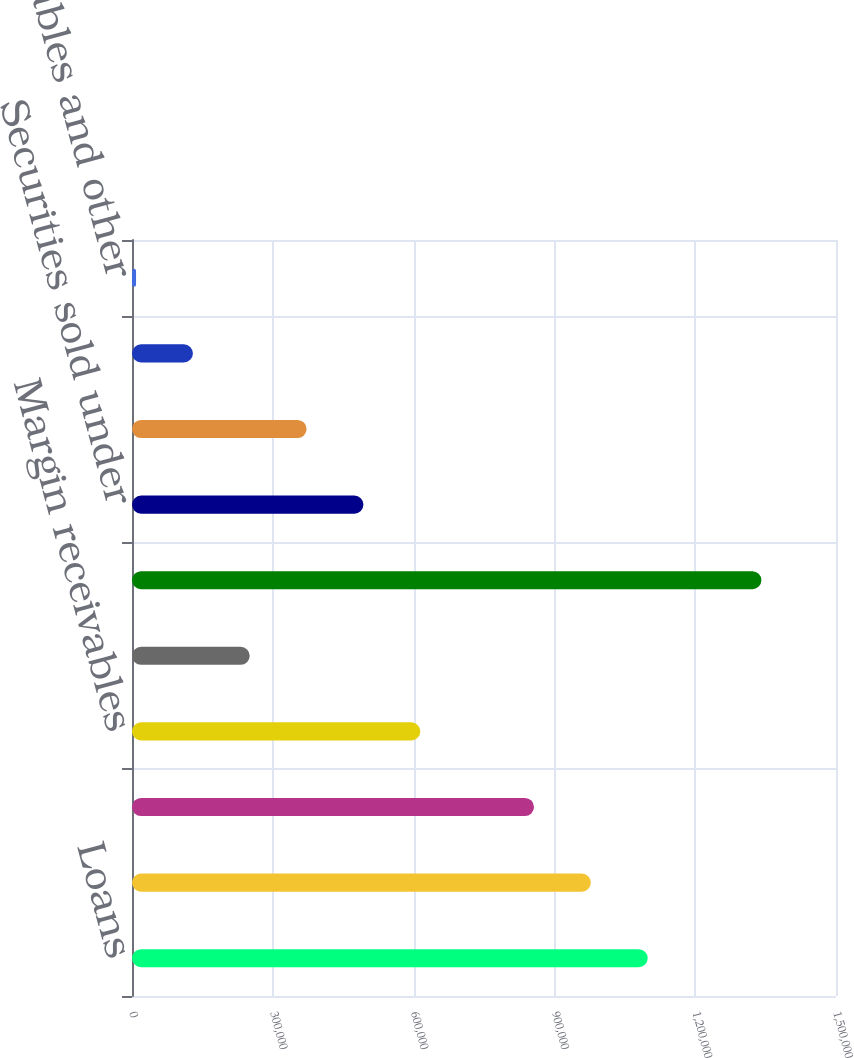<chart> <loc_0><loc_0><loc_500><loc_500><bar_chart><fcel>Loans<fcel>Available-for-sale securities<fcel>Held-to-maturity securities<fcel>Margin receivables<fcel>Securities borrowed and other<fcel>Total operating interest<fcel>Securities sold under<fcel>FHLB advances and other<fcel>Deposits<fcel>Customer payables and other<nl><fcel>1.09878e+06<fcel>977652<fcel>856522<fcel>614262<fcel>250871<fcel>1.34104e+06<fcel>493131<fcel>372001<fcel>129741<fcel>8611<nl></chart> 